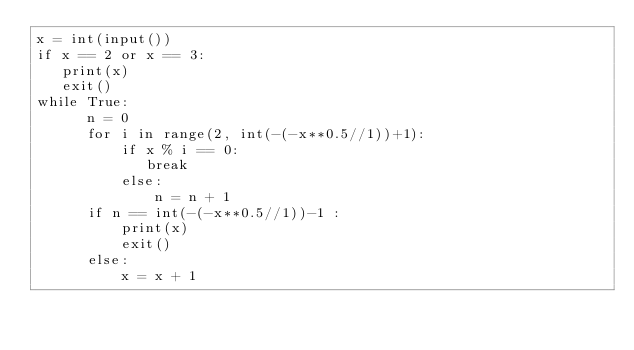<code> <loc_0><loc_0><loc_500><loc_500><_Python_>x = int(input())
if x == 2 or x == 3:
   print(x)
   exit()
while True:
      n = 0
      for i in range(2, int(-(-x**0.5//1))+1):
          if x % i == 0:
             break
          else:
              n = n + 1
      if n == int(-(-x**0.5//1))-1 :
          print(x)
          exit()
      else:
          x = x + 1</code> 